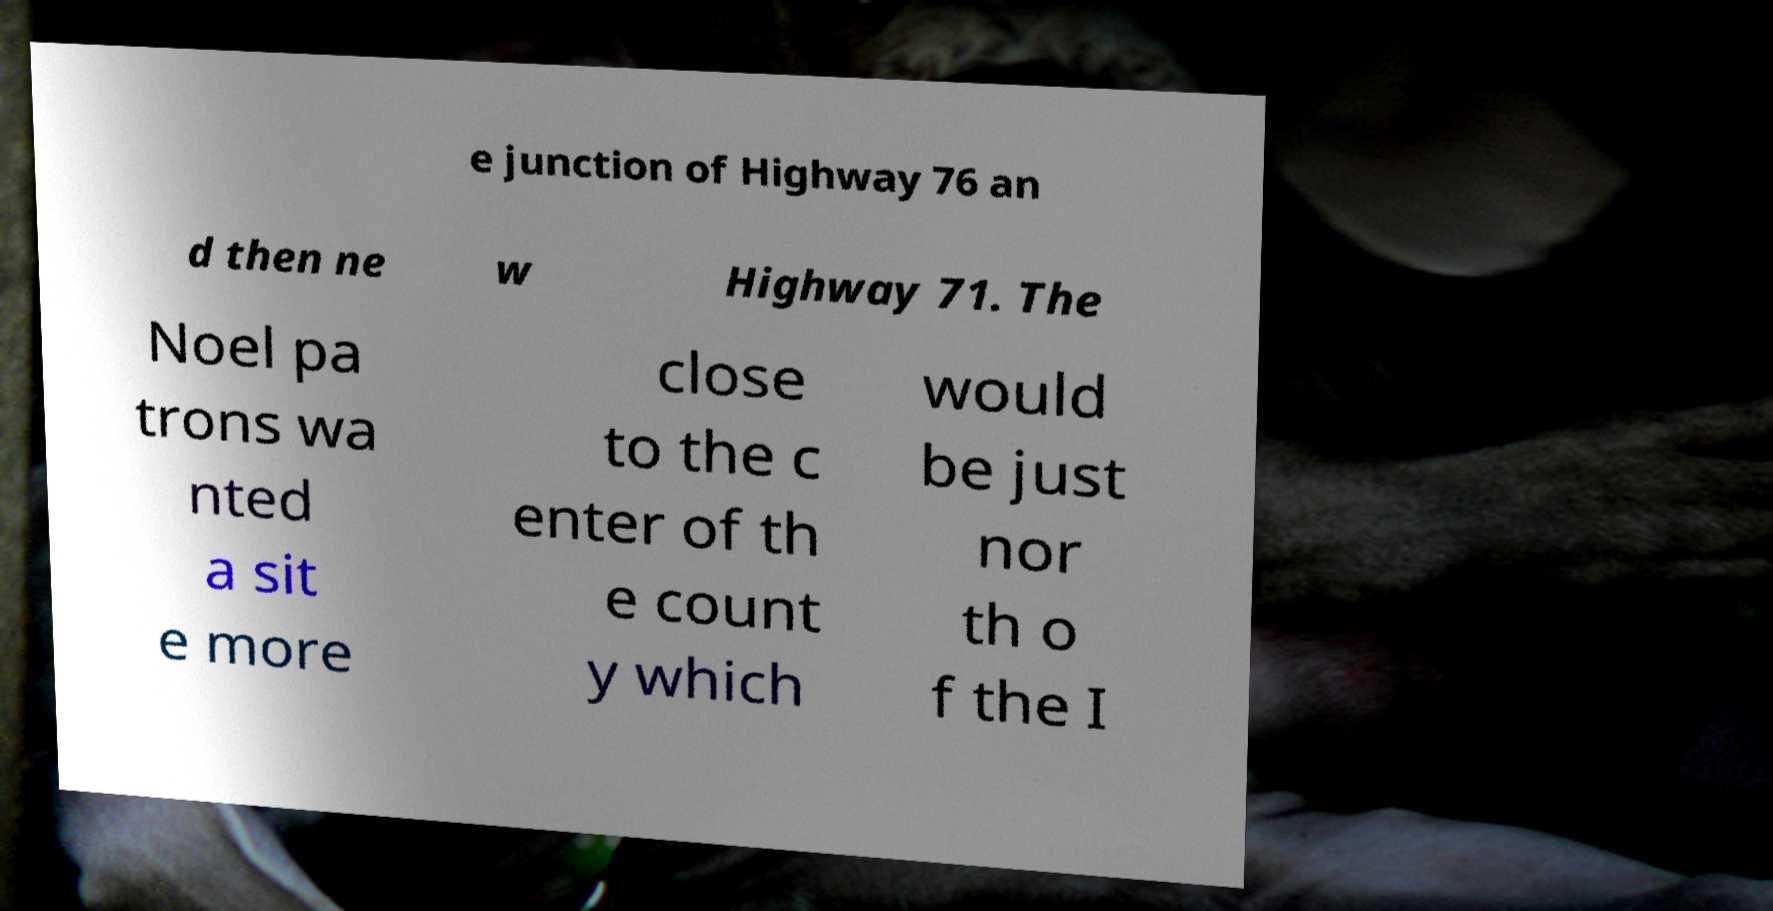There's text embedded in this image that I need extracted. Can you transcribe it verbatim? e junction of Highway 76 an d then ne w Highway 71. The Noel pa trons wa nted a sit e more close to the c enter of th e count y which would be just nor th o f the I 